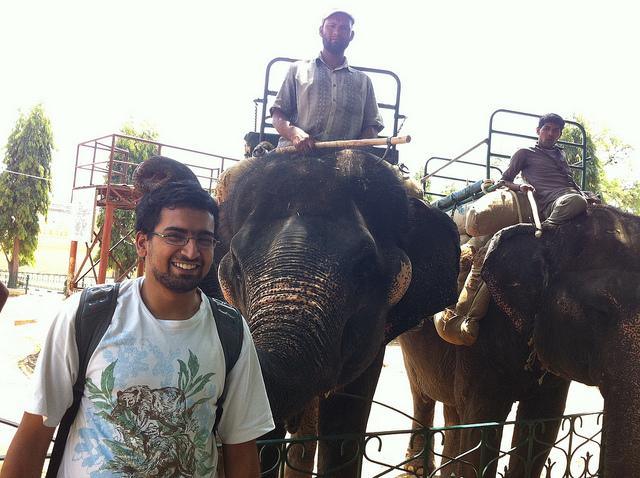Do these animals have jobs to do?
Quick response, please. Yes. Are the people on the elephants male or female?
Answer briefly. Male. Are the people and elephants in a zoo?
Concise answer only. No. 